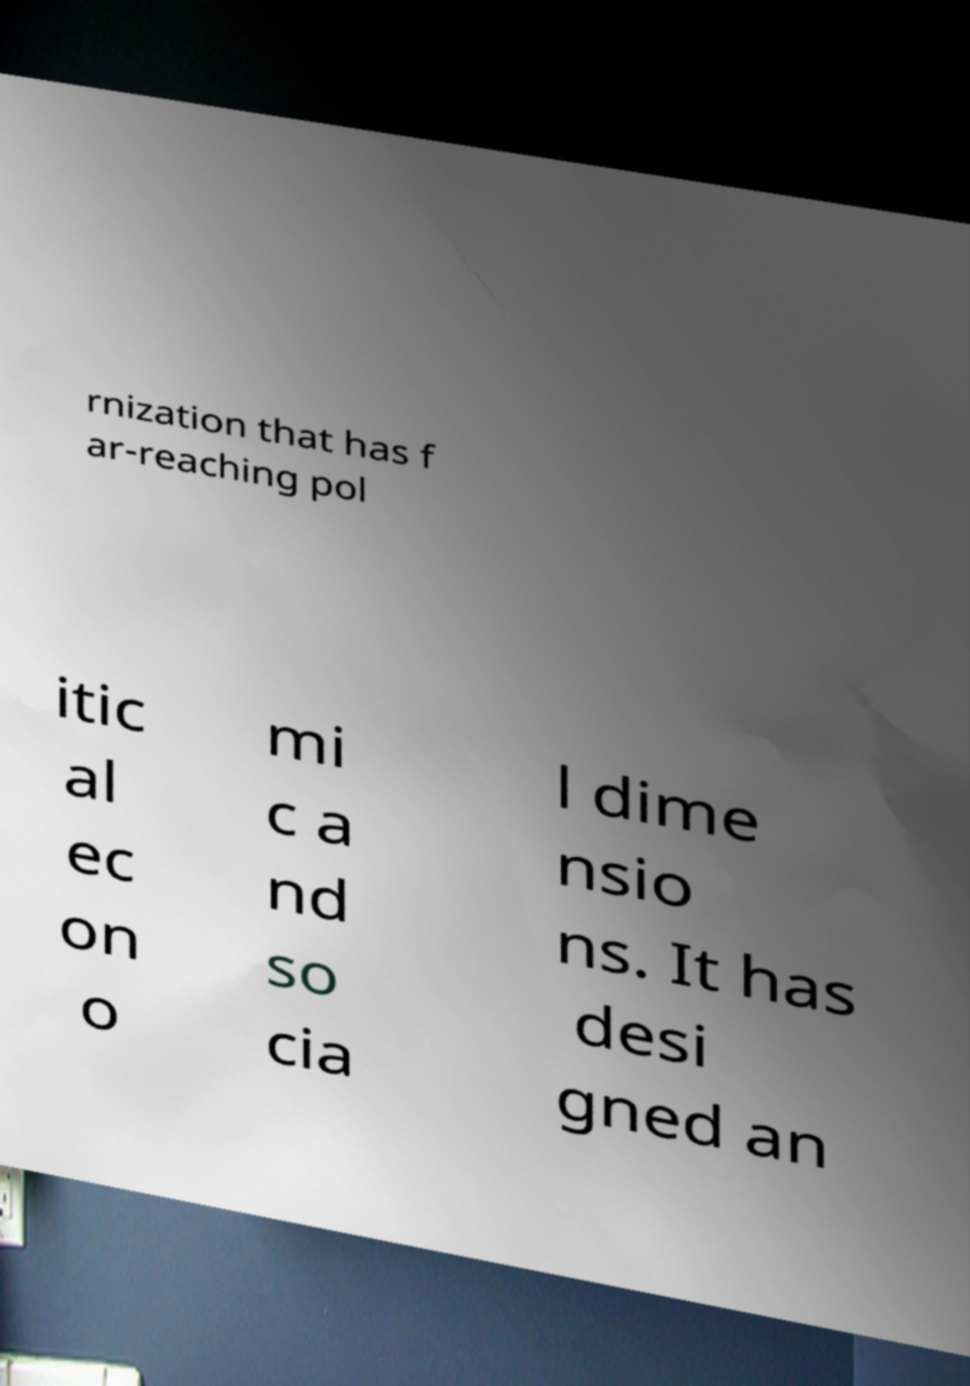What messages or text are displayed in this image? I need them in a readable, typed format. rnization that has f ar-reaching pol itic al ec on o mi c a nd so cia l dime nsio ns. It has desi gned an 